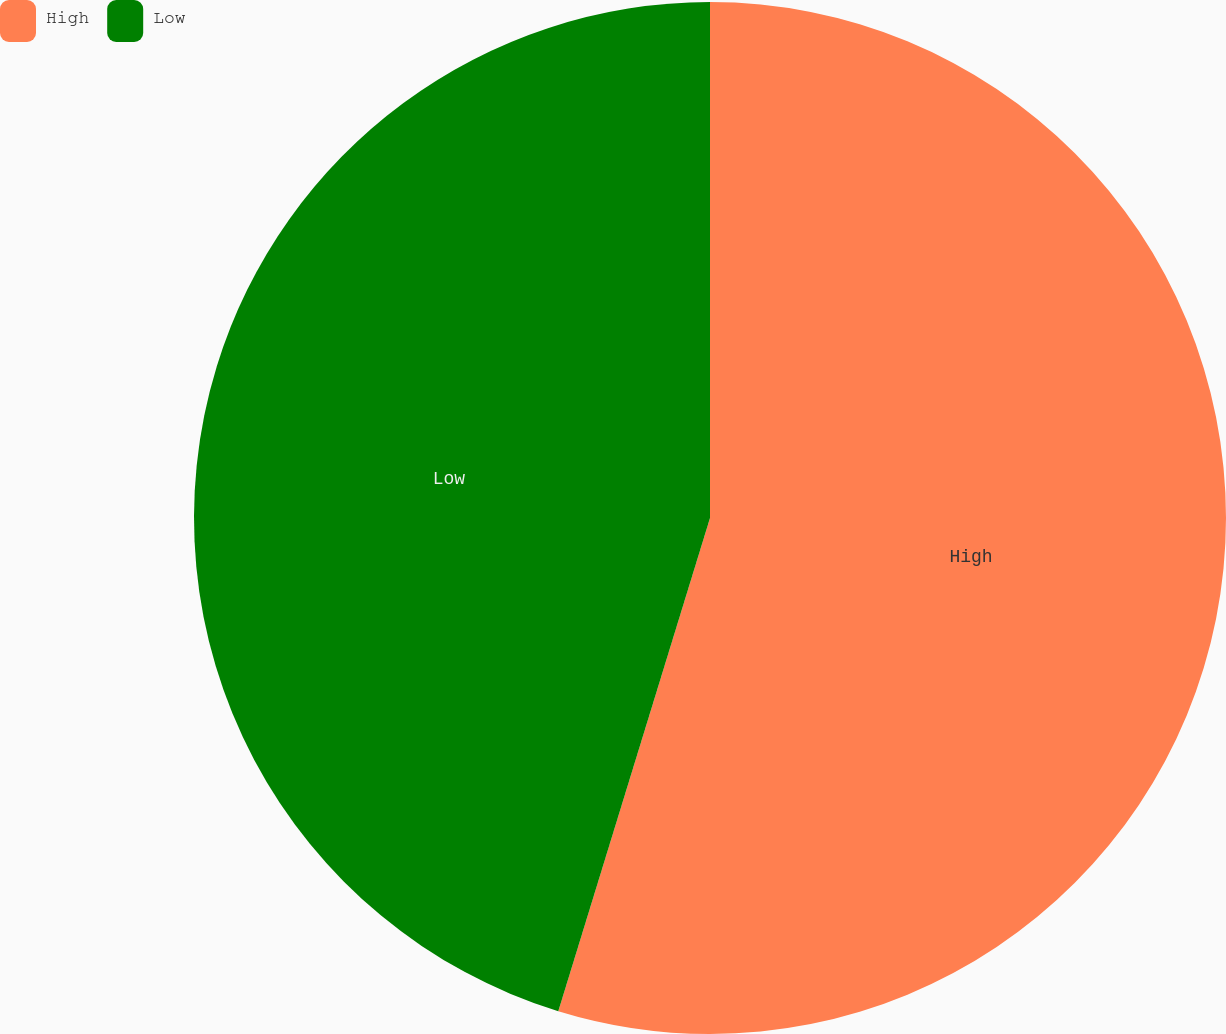Convert chart. <chart><loc_0><loc_0><loc_500><loc_500><pie_chart><fcel>High<fcel>Low<nl><fcel>54.75%<fcel>45.25%<nl></chart> 